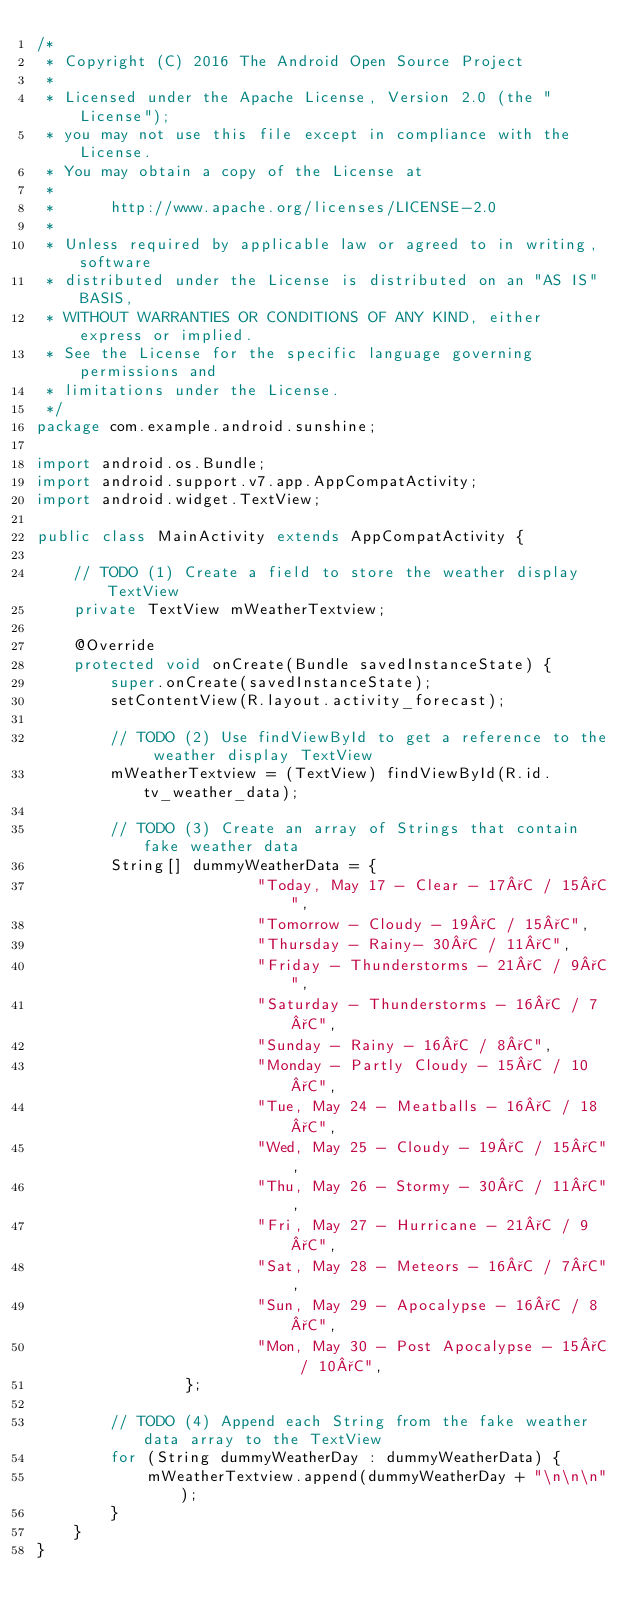Convert code to text. <code><loc_0><loc_0><loc_500><loc_500><_Java_>/*
 * Copyright (C) 2016 The Android Open Source Project
 *
 * Licensed under the Apache License, Version 2.0 (the "License");
 * you may not use this file except in compliance with the License.
 * You may obtain a copy of the License at
 *
 *      http://www.apache.org/licenses/LICENSE-2.0
 *
 * Unless required by applicable law or agreed to in writing, software
 * distributed under the License is distributed on an "AS IS" BASIS,
 * WITHOUT WARRANTIES OR CONDITIONS OF ANY KIND, either express or implied.
 * See the License for the specific language governing permissions and
 * limitations under the License.
 */
package com.example.android.sunshine;

import android.os.Bundle;
import android.support.v7.app.AppCompatActivity;
import android.widget.TextView;

public class MainActivity extends AppCompatActivity {

    // TODO (1) Create a field to store the weather display TextView
    private TextView mWeatherTextview;

    @Override
    protected void onCreate(Bundle savedInstanceState) {
        super.onCreate(savedInstanceState);
        setContentView(R.layout.activity_forecast);

        // TODO (2) Use findViewById to get a reference to the weather display TextView
        mWeatherTextview = (TextView) findViewById(R.id.tv_weather_data);

        // TODO (3) Create an array of Strings that contain fake weather data
        String[] dummyWeatherData = {
                        "Today, May 17 - Clear - 17°C / 15°C",
                        "Tomorrow - Cloudy - 19°C / 15°C",
                        "Thursday - Rainy- 30°C / 11°C",
                        "Friday - Thunderstorms - 21°C / 9°C",
                        "Saturday - Thunderstorms - 16°C / 7°C",
                        "Sunday - Rainy - 16°C / 8°C",
                        "Monday - Partly Cloudy - 15°C / 10°C",
                        "Tue, May 24 - Meatballs - 16°C / 18°C",
                        "Wed, May 25 - Cloudy - 19°C / 15°C",
                        "Thu, May 26 - Stormy - 30°C / 11°C",
                        "Fri, May 27 - Hurricane - 21°C / 9°C",
                        "Sat, May 28 - Meteors - 16°C / 7°C",
                        "Sun, May 29 - Apocalypse - 16°C / 8°C",
                        "Mon, May 30 - Post Apocalypse - 15°C / 10°C",
                };

        // TODO (4) Append each String from the fake weather data array to the TextView
        for (String dummyWeatherDay : dummyWeatherData) {
            mWeatherTextview.append(dummyWeatherDay + "\n\n\n");
        }
    }
}</code> 